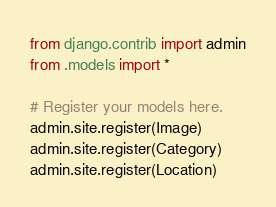Convert code to text. <code><loc_0><loc_0><loc_500><loc_500><_Python_>from django.contrib import admin
from .models import *

# Register your models here.
admin.site.register(Image)
admin.site.register(Category)
admin.site.register(Location)
</code> 